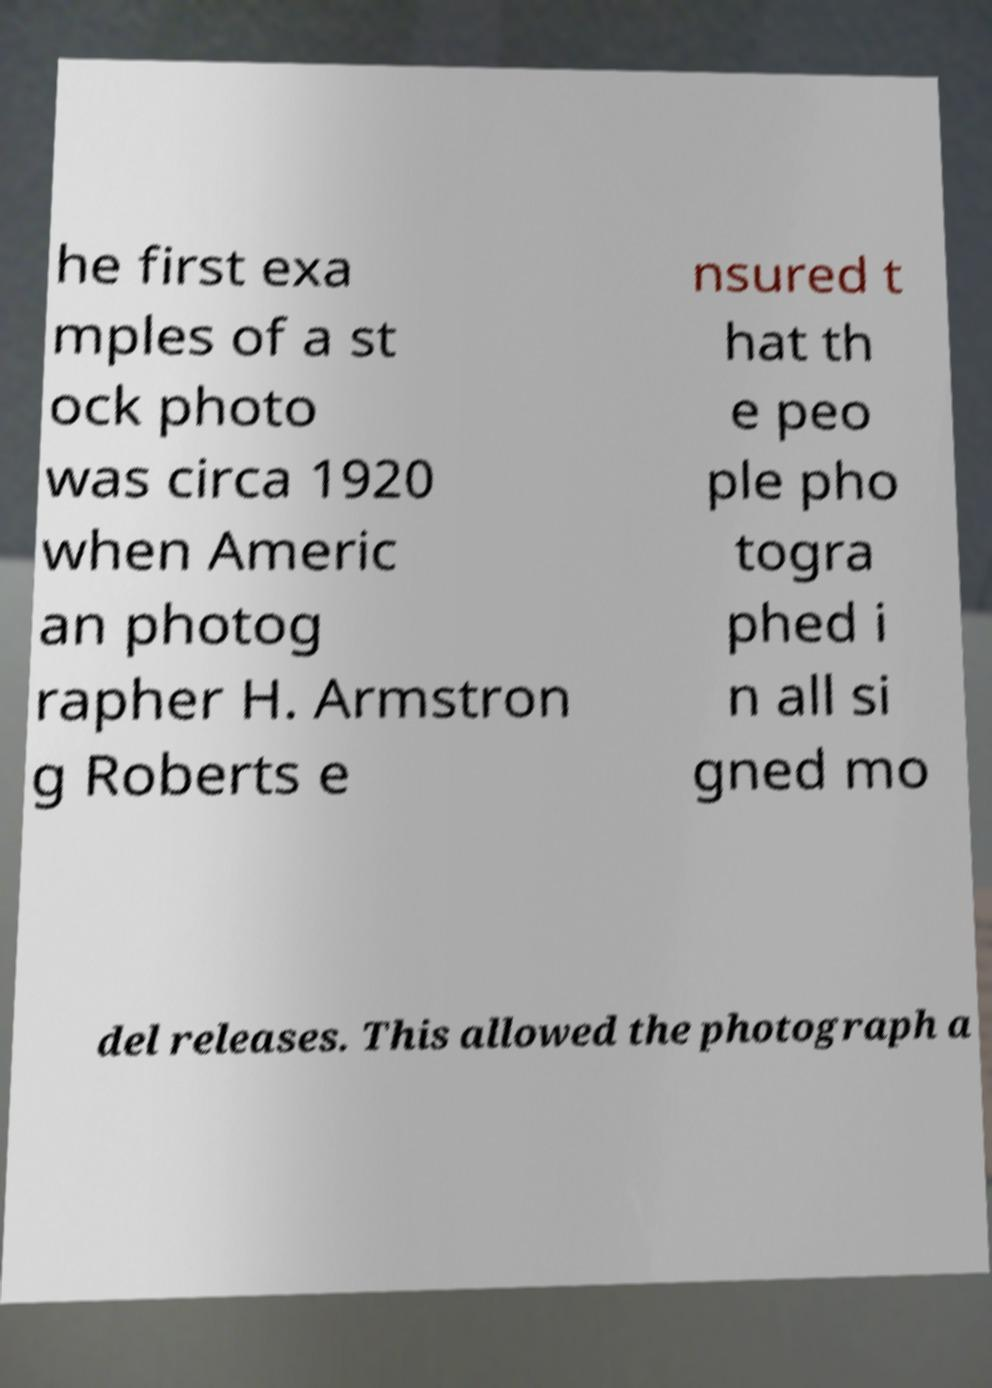I need the written content from this picture converted into text. Can you do that? he first exa mples of a st ock photo was circa 1920 when Americ an photog rapher H. Armstron g Roberts e nsured t hat th e peo ple pho togra phed i n all si gned mo del releases. This allowed the photograph a 